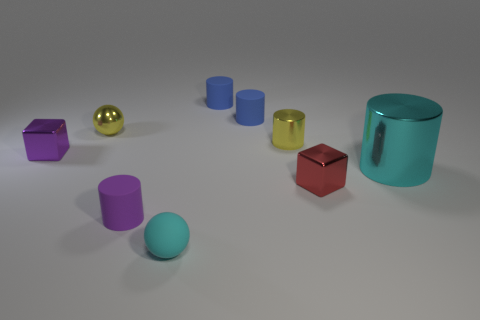What number of other small metallic objects are the same shape as the small red metallic object? There are two small metallic objects that share the same cubical shape as the small red metallic object. 